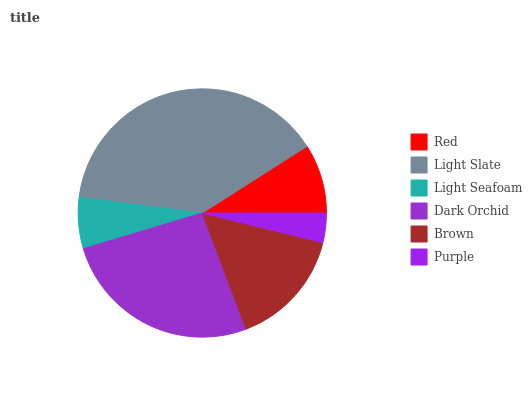Is Purple the minimum?
Answer yes or no. Yes. Is Light Slate the maximum?
Answer yes or no. Yes. Is Light Seafoam the minimum?
Answer yes or no. No. Is Light Seafoam the maximum?
Answer yes or no. No. Is Light Slate greater than Light Seafoam?
Answer yes or no. Yes. Is Light Seafoam less than Light Slate?
Answer yes or no. Yes. Is Light Seafoam greater than Light Slate?
Answer yes or no. No. Is Light Slate less than Light Seafoam?
Answer yes or no. No. Is Brown the high median?
Answer yes or no. Yes. Is Red the low median?
Answer yes or no. Yes. Is Light Seafoam the high median?
Answer yes or no. No. Is Light Seafoam the low median?
Answer yes or no. No. 